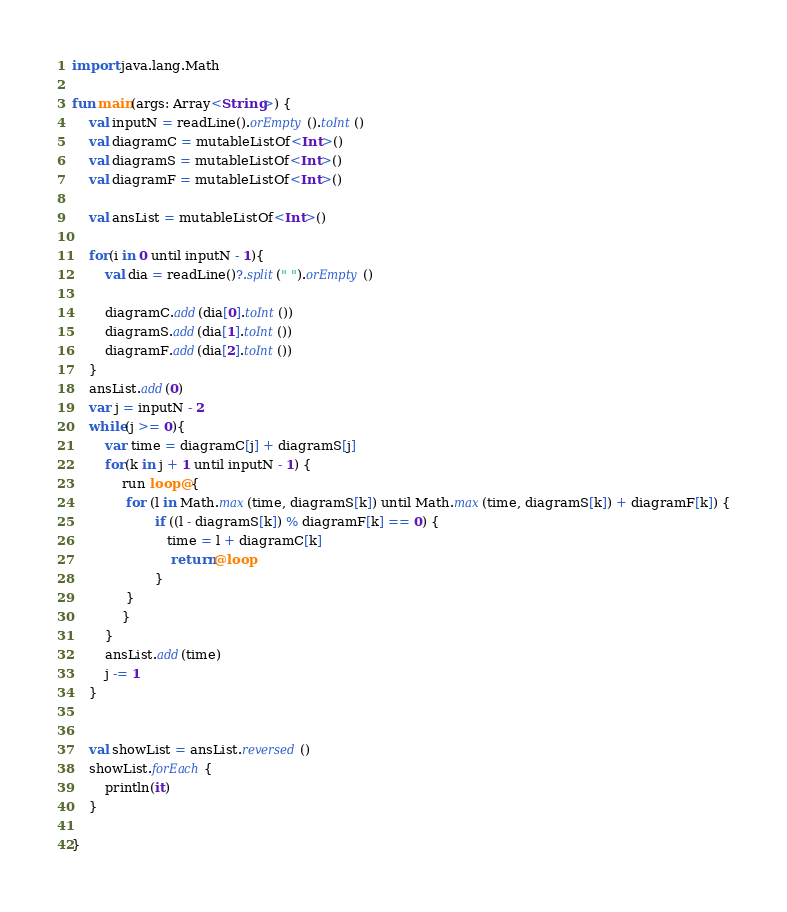Convert code to text. <code><loc_0><loc_0><loc_500><loc_500><_Kotlin_>import java.lang.Math

fun main(args: Array<String>) {
    val inputN = readLine().orEmpty().toInt()
    val diagramC = mutableListOf<Int>()
    val diagramS = mutableListOf<Int>()
    val diagramF = mutableListOf<Int>()

    val ansList = mutableListOf<Int>()

    for(i in 0 until inputN - 1){
        val dia = readLine()?.split(" ").orEmpty()

        diagramC.add(dia[0].toInt())
        diagramS.add(dia[1].toInt())
        diagramF.add(dia[2].toInt())
    }
    ansList.add(0)
    var j = inputN - 2
    while(j >= 0){
        var time = diagramC[j] + diagramS[j]
        for(k in j + 1 until inputN - 1) {
            run loop@{
             for (l in Math.max(time, diagramS[k]) until Math.max(time, diagramS[k]) + diagramF[k]) {
                    if ((l - diagramS[k]) % diagramF[k] == 0) {
                       time = l + diagramC[k]
                        return@loop
                    }
             }
            }
        }
        ansList.add(time)
        j -= 1
    }


    val showList = ansList.reversed()
    showList.forEach{
        println(it)
    }

}</code> 